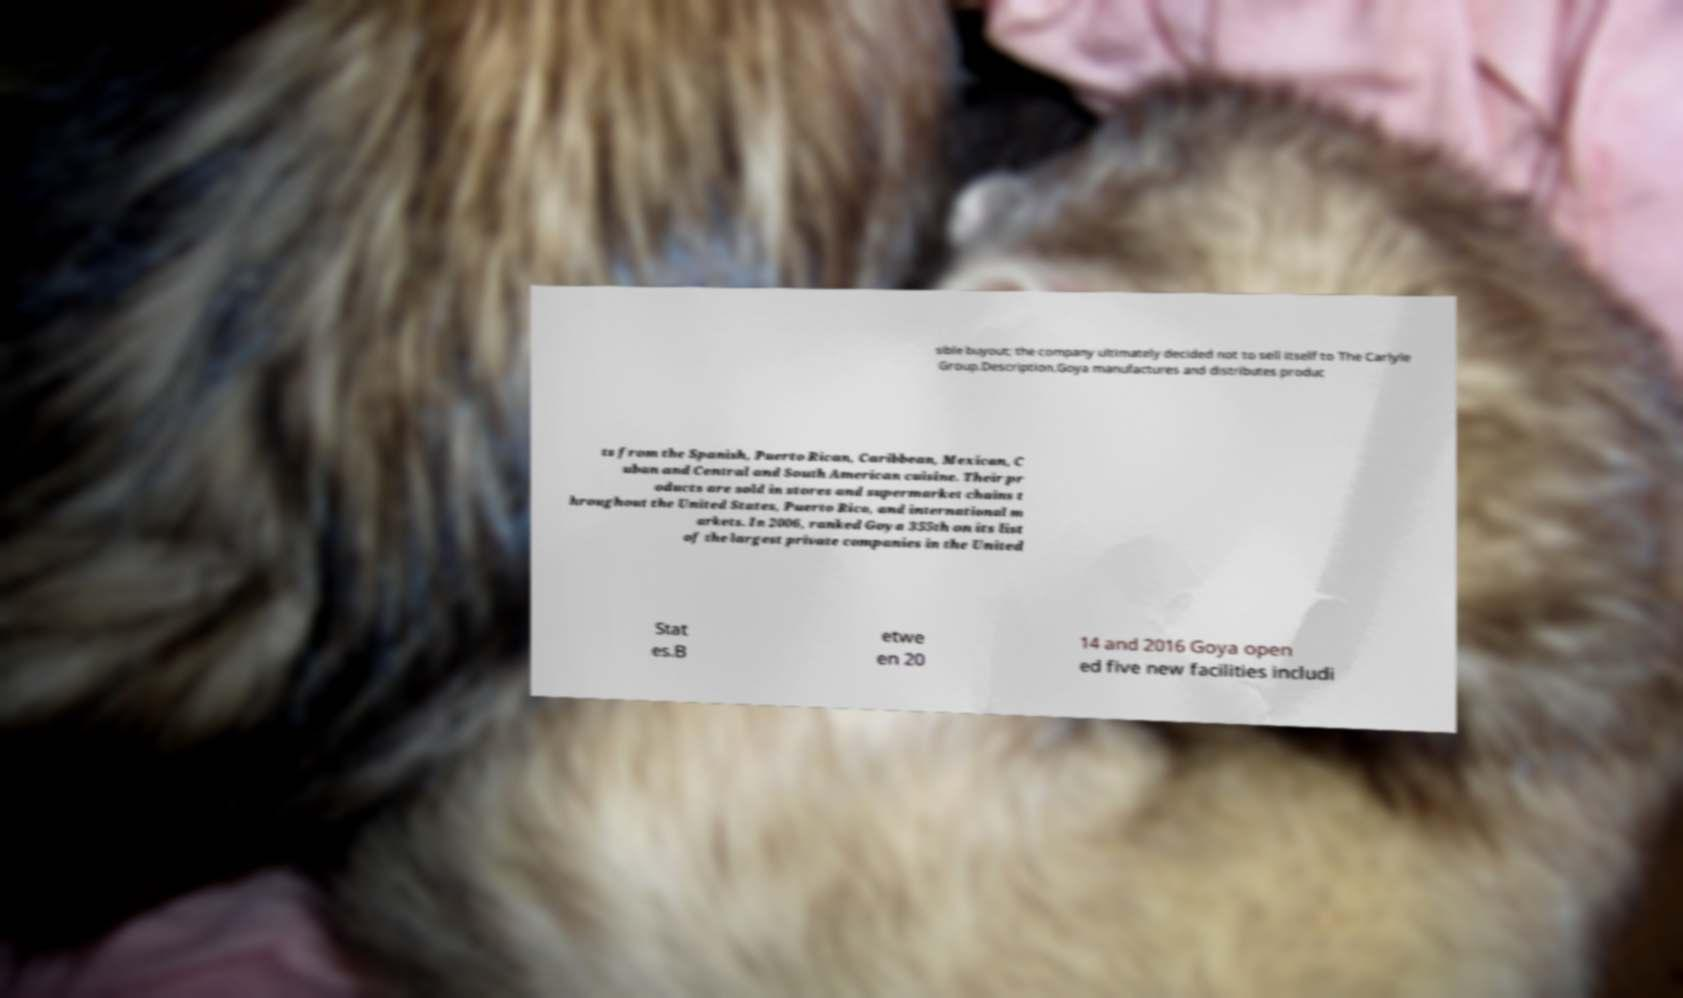There's text embedded in this image that I need extracted. Can you transcribe it verbatim? sible buyout; the company ultimately decided not to sell itself to The Carlyle Group.Description.Goya manufactures and distributes produc ts from the Spanish, Puerto Rican, Caribbean, Mexican, C uban and Central and South American cuisine. Their pr oducts are sold in stores and supermarket chains t hroughout the United States, Puerto Rico, and international m arkets. In 2006, ranked Goya 355th on its list of the largest private companies in the United Stat es.B etwe en 20 14 and 2016 Goya open ed five new facilities includi 